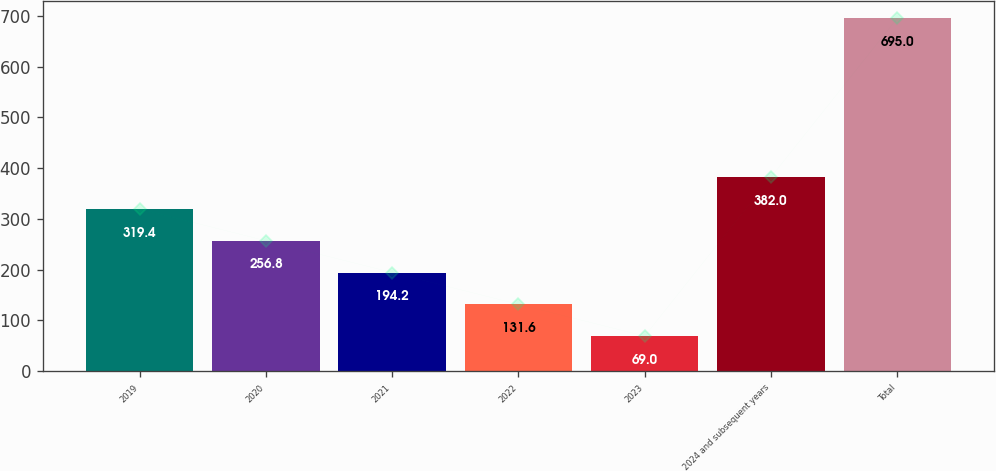Convert chart to OTSL. <chart><loc_0><loc_0><loc_500><loc_500><bar_chart><fcel>2019<fcel>2020<fcel>2021<fcel>2022<fcel>2023<fcel>2024 and subsequent years<fcel>Total<nl><fcel>319.4<fcel>256.8<fcel>194.2<fcel>131.6<fcel>69<fcel>382<fcel>695<nl></chart> 